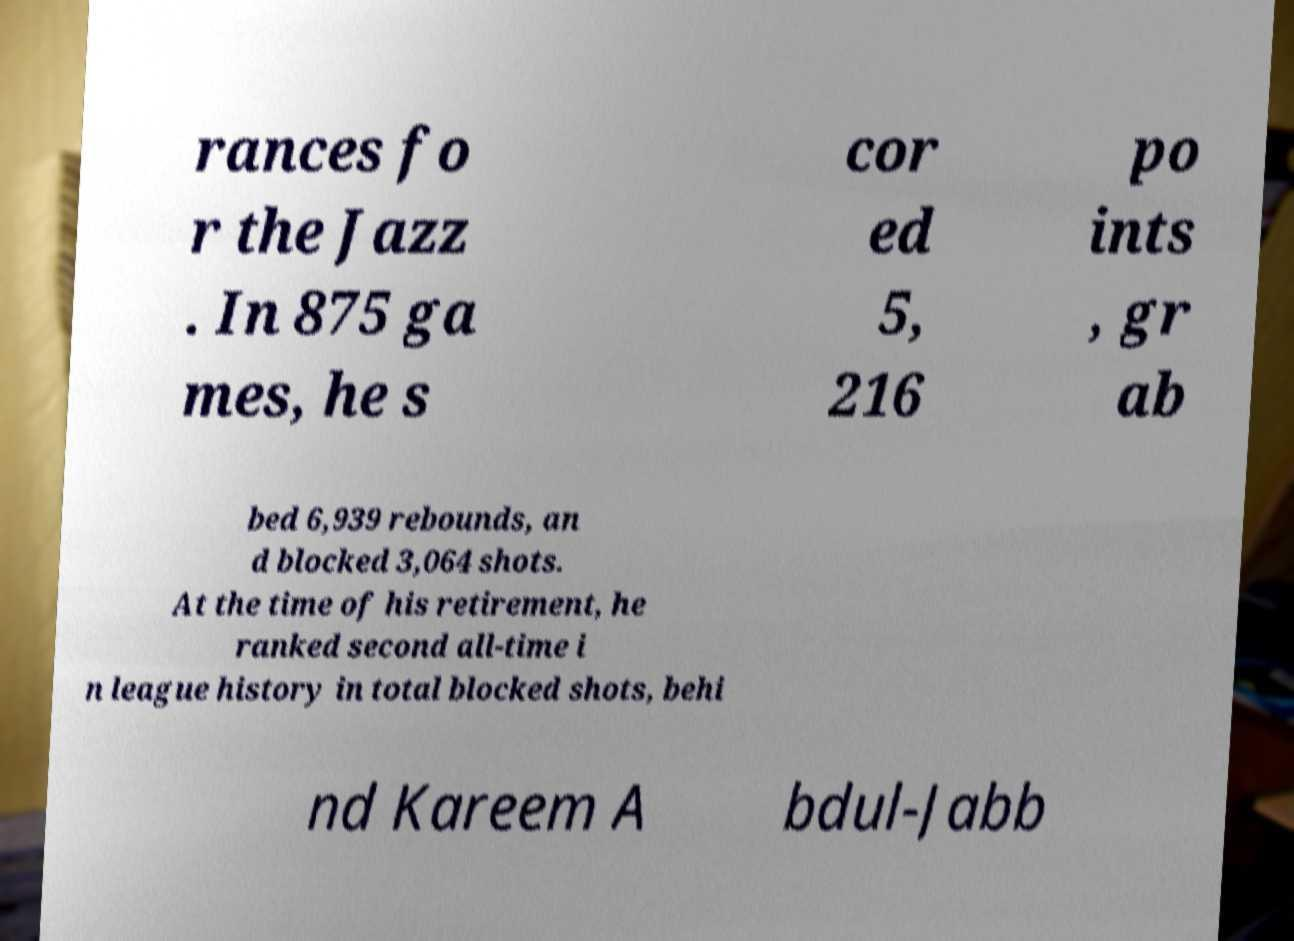Can you read and provide the text displayed in the image?This photo seems to have some interesting text. Can you extract and type it out for me? rances fo r the Jazz . In 875 ga mes, he s cor ed 5, 216 po ints , gr ab bed 6,939 rebounds, an d blocked 3,064 shots. At the time of his retirement, he ranked second all-time i n league history in total blocked shots, behi nd Kareem A bdul-Jabb 